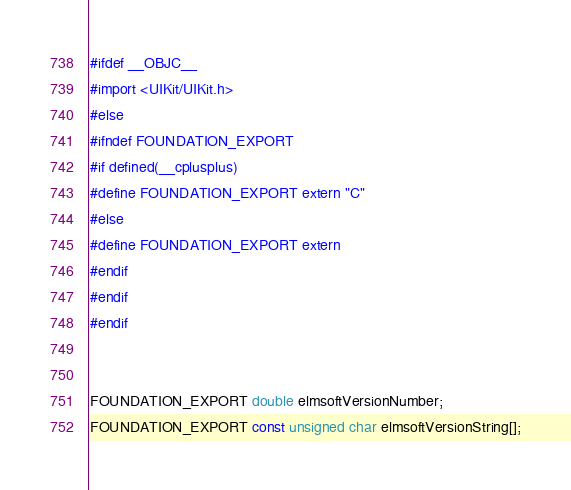<code> <loc_0><loc_0><loc_500><loc_500><_C_>#ifdef __OBJC__
#import <UIKit/UIKit.h>
#else
#ifndef FOUNDATION_EXPORT
#if defined(__cplusplus)
#define FOUNDATION_EXPORT extern "C"
#else
#define FOUNDATION_EXPORT extern
#endif
#endif
#endif


FOUNDATION_EXPORT double elmsoftVersionNumber;
FOUNDATION_EXPORT const unsigned char elmsoftVersionString[];

</code> 